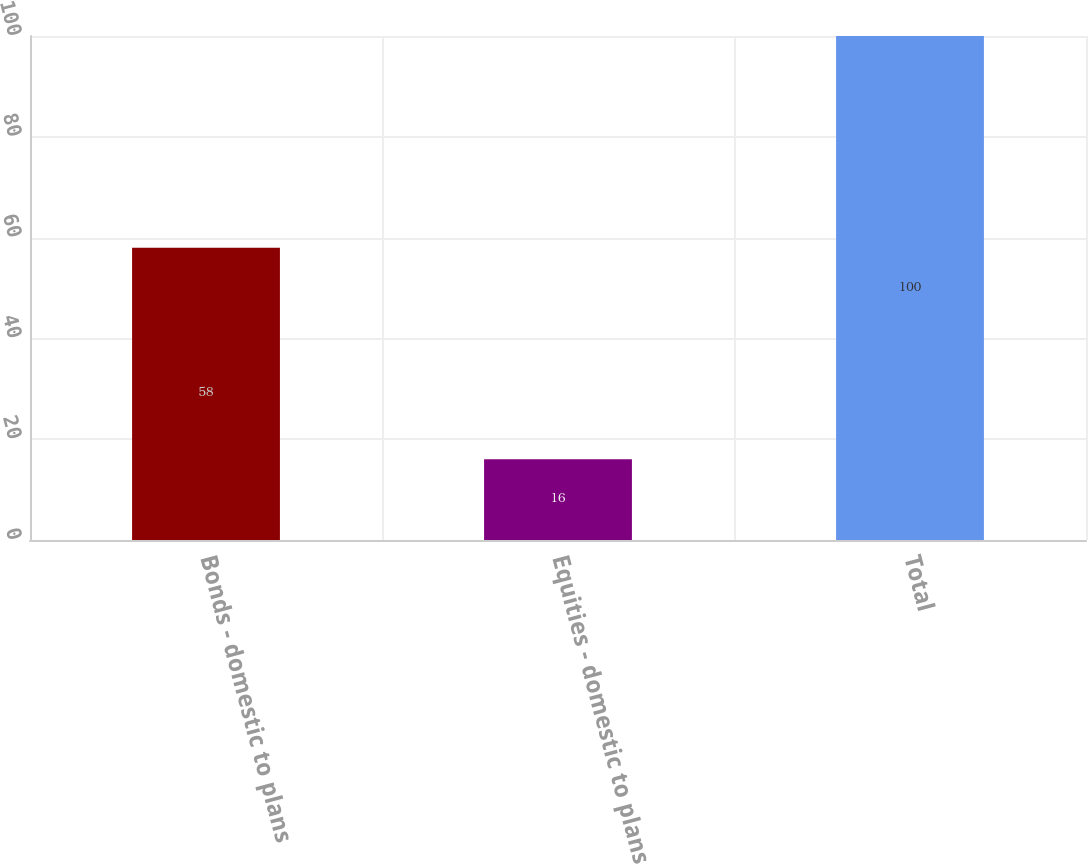Convert chart to OTSL. <chart><loc_0><loc_0><loc_500><loc_500><bar_chart><fcel>Bonds - domestic to plans<fcel>Equities - domestic to plans<fcel>Total<nl><fcel>58<fcel>16<fcel>100<nl></chart> 